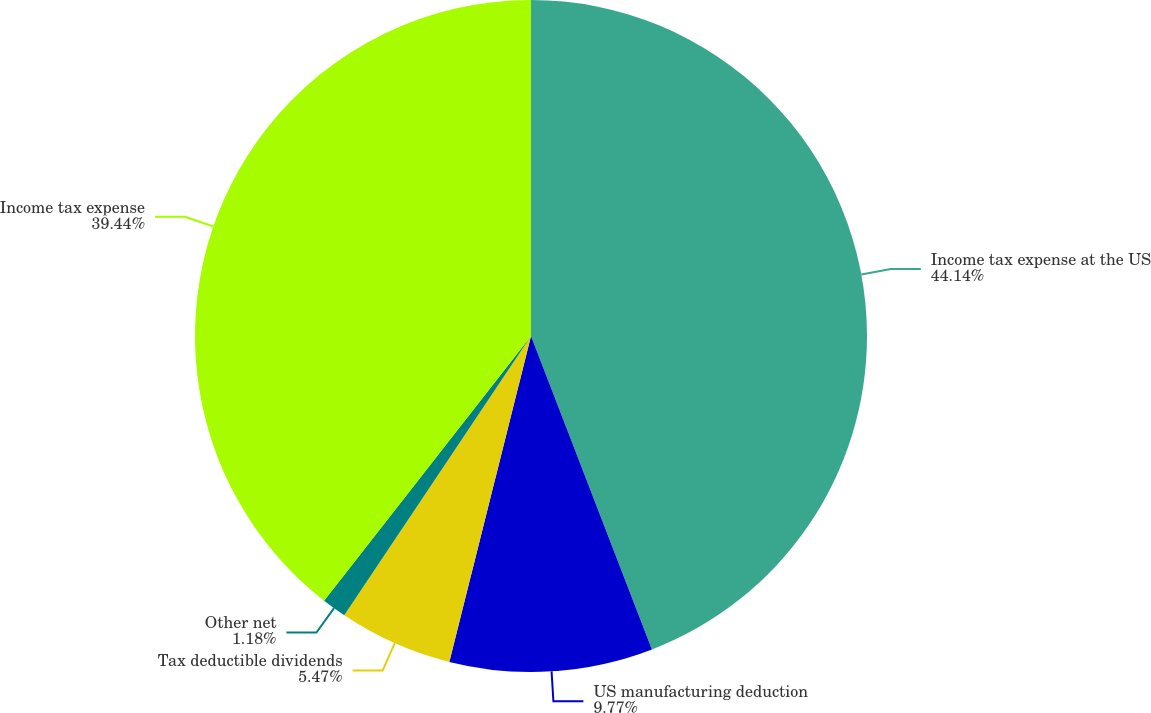Convert chart. <chart><loc_0><loc_0><loc_500><loc_500><pie_chart><fcel>Income tax expense at the US<fcel>US manufacturing deduction<fcel>Tax deductible dividends<fcel>Other net<fcel>Income tax expense<nl><fcel>44.14%<fcel>9.77%<fcel>5.47%<fcel>1.18%<fcel>39.44%<nl></chart> 